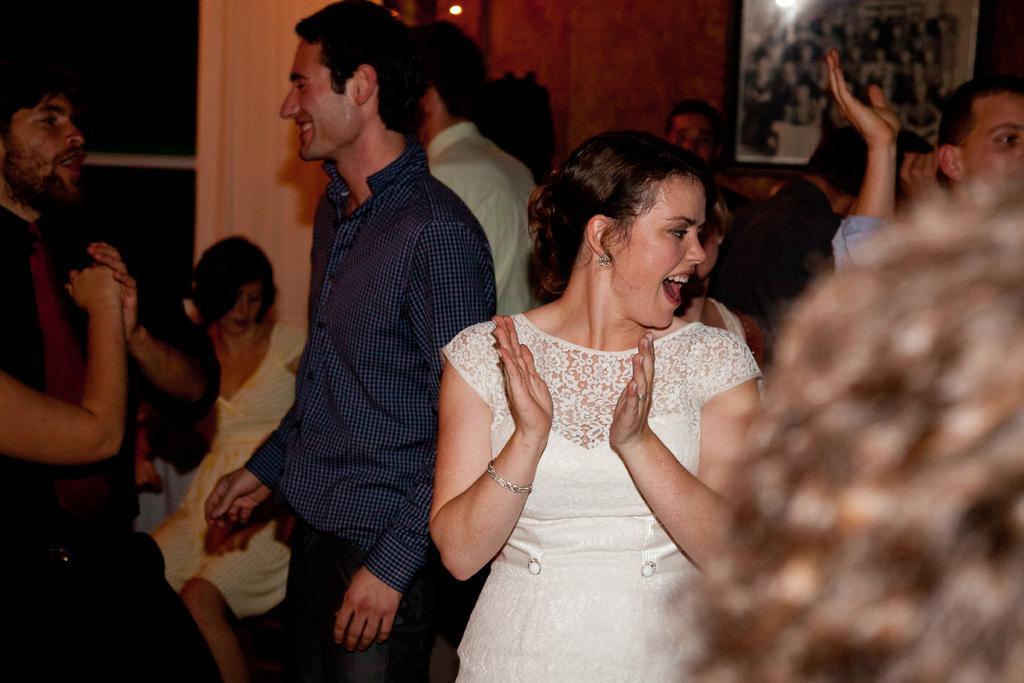Describe this image in one or two sentences. This is the picture of a room. In this image there is a woman with white dress is standing and smiling. There is a person with blue and black check shirt is standing and smiling. At the back there are group of people. There is a frame on the wall and there is a door. At the top there is a light. 